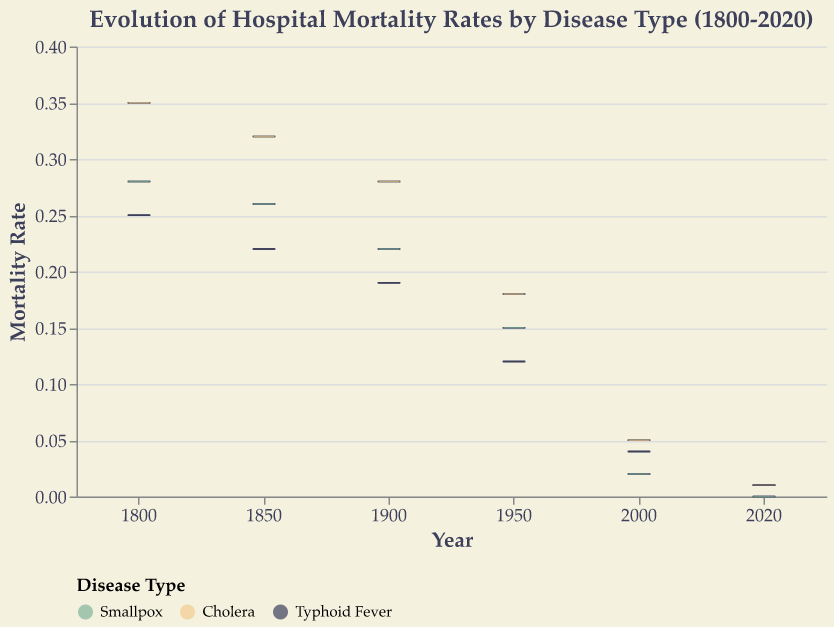What's the title of the figure? The title of the figure is displayed at the top and it reads "Evolution of Hospital Mortality Rates by Disease Type (1800-2020)"
Answer: Evolution of Hospital Mortality Rates by Disease Type (1800-2020) Which year recorded the lowest median mortality rate for Cholera? By examining the middle line (median) inside the box for each year, 2020 shows the lowest median mortality rate for Cholera
Answer: 2020 What's the color representing Typhoid Fever in the plot? The legend indicates the colors used for each disease: Typhoid Fever is represented by the color that matches the legend entry for Typhoid Fever
Answer: Dark grey How does the median mortality rate for Smallpox change from 1800 to 2020? Observe the position of the median line for Smallpox across different years. It starts relatively high in 1800 and decreases significantly towards 2020, eventually reaching zero in 2020
Answer: Decreases to zero Which disease had the highest mortality rate in the year 1800? Compare the height of the whiskers (lines extending from the box) for each disease in 1800; Cholera's whiskers reach the highest point
Answer: Cholera Describe the spread of mortality rates for Typhoid Fever in 1900. The boxplot for Typhoid Fever in 1900 shows the interquartile range (IQR) as the height of the box, with whiskers indicating the full spread of the data from minimum to maximum
Answer: The interquartile range is relatively narrow with a slightly larger whisker spread What's the difference in the median mortality rate for Smallpox between 1850 and 1900? The median line for Smallpox is slightly lower in 1900 compared to 1850, indicating a decrease. Subtract the median of 1900 from the median of 1850
Answer: 0.04 Which disease shows the most significant decrease in mortality rate from 1800 to 2020? By comparing the median lines within the boxes across the years for each disease, Smallpox shows the most drastic decline, reaching a mortality rate of zero in 2020
Answer: Smallpox How do the mortality rates for Cholera and Typhoid Fever compare in 1950? Compare both the boxes and whiskers for Cholera and Typhoid Fever in 1950, noting that the median line for Cholera is higher than for Typhoid Fever
Answer: Cholera is higher 